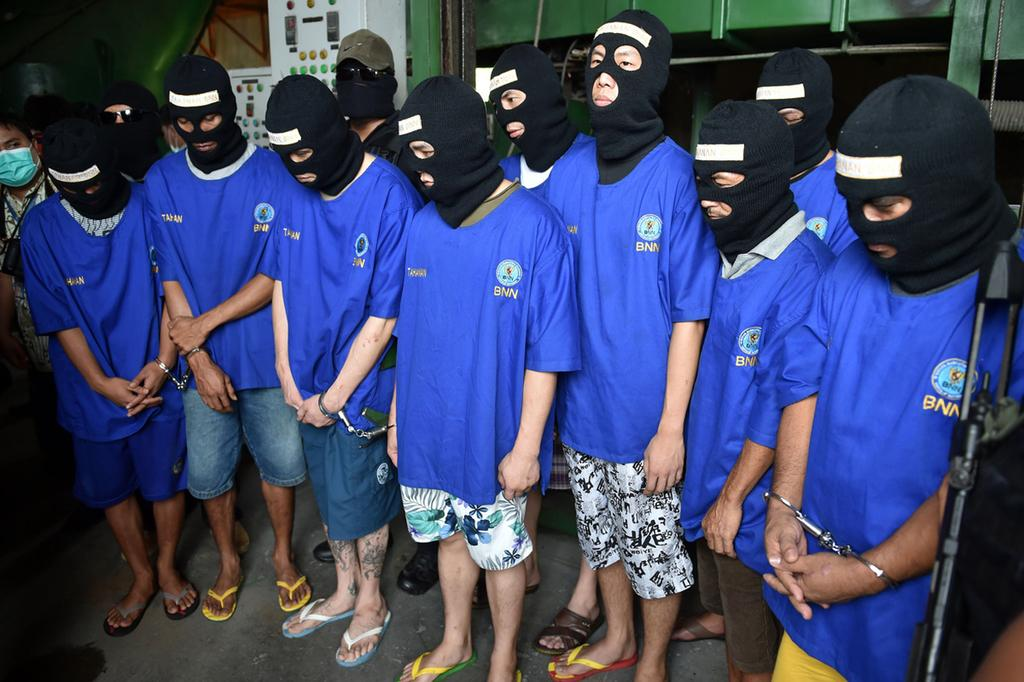What is the main subject of the image? The main subject of the image is a group of people. What are the people wearing in the image? The people are wearing blue color t-shirts in the image. Can you describe any additional features of the people in the image? Yes, the people have masks over their heads in the image. What type of memory is being used by the people in the image? There is no indication in the image of any specific type of memory being used by the people. What is the limit of the cream that can be seen in the image? There is no cream present in the image. 